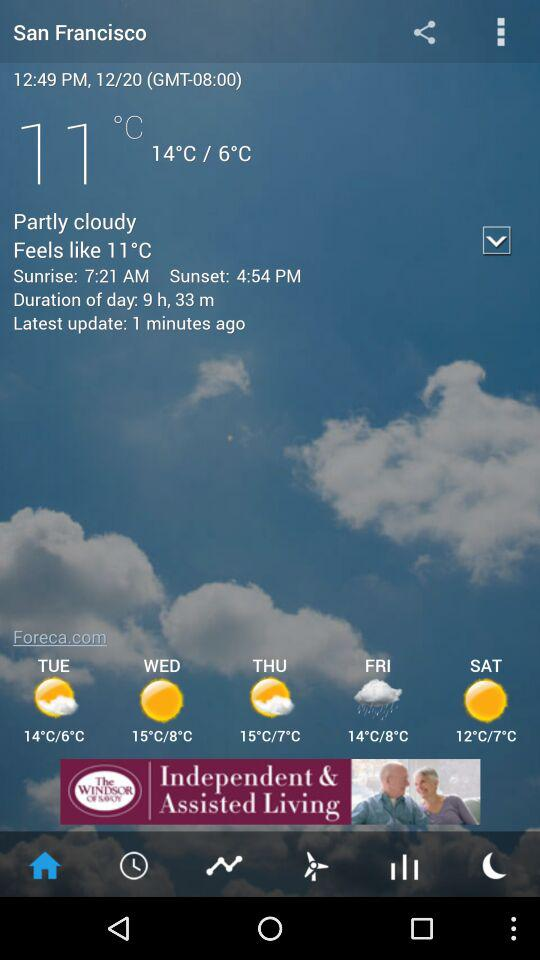What is an interesting fact about the weather in San Francisco? San Francisco is known for its microclimates, where weather conditions can vary dramatically between different neighborhoods; often, coastal fog rolls in, resulting in cooler temperatures in certain areas, while others may remain sunny and warm. 